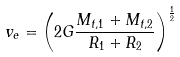Convert formula to latex. <formula><loc_0><loc_0><loc_500><loc_500>v _ { e } = \left ( 2 G \frac { M _ { t , 1 } + M _ { t , 2 } } { R _ { 1 } + R _ { 2 } } \right ) ^ { \frac { 1 } { 2 } }</formula> 